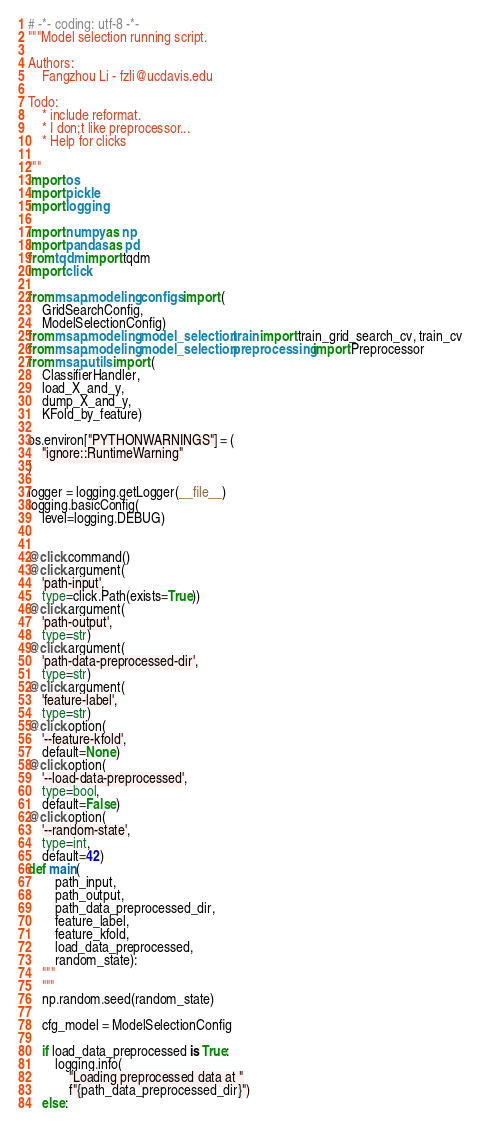Convert code to text. <code><loc_0><loc_0><loc_500><loc_500><_Python_># -*- coding: utf-8 -*-
"""Model selection running script.

Authors:
    Fangzhou Li - fzli@ucdavis.edu

Todo:
    * include reformat.
    * I don;t like preprocessor...
    * Help for clicks

"""
import os
import pickle
import logging

import numpy as np
import pandas as pd
from tqdm import tqdm
import click

from msap.modeling.configs import (
    GridSearchConfig,
    ModelSelectionConfig)
from msap.modeling.model_selection.train import train_grid_search_cv, train_cv
from msap.modeling.model_selection.preprocessing import Preprocessor
from msap.utils import (
    ClassifierHandler,
    load_X_and_y,
    dump_X_and_y,
    KFold_by_feature)

os.environ["PYTHONWARNINGS"] = (
    "ignore::RuntimeWarning"
)

logger = logging.getLogger(__file__)
logging.basicConfig(
    level=logging.DEBUG)


@click.command()
@click.argument(
    'path-input',
    type=click.Path(exists=True))
@click.argument(
    'path-output',
    type=str)
@click.argument(
    'path-data-preprocessed-dir',
    type=str)
@click.argument(
    'feature-label',
    type=str)
@click.option(
    '--feature-kfold',
    default=None)
@click.option(
    '--load-data-preprocessed',
    type=bool,
    default=False)
@click.option(
    '--random-state',
    type=int,
    default=42)
def main(
        path_input,
        path_output,
        path_data_preprocessed_dir,
        feature_label,
        feature_kfold,
        load_data_preprocessed,
        random_state):
    """
    """
    np.random.seed(random_state)

    cfg_model = ModelSelectionConfig

    if load_data_preprocessed is True:
        logging.info(
            "Loading preprocessed data at "
            f"{path_data_preprocessed_dir}")
    else:</code> 